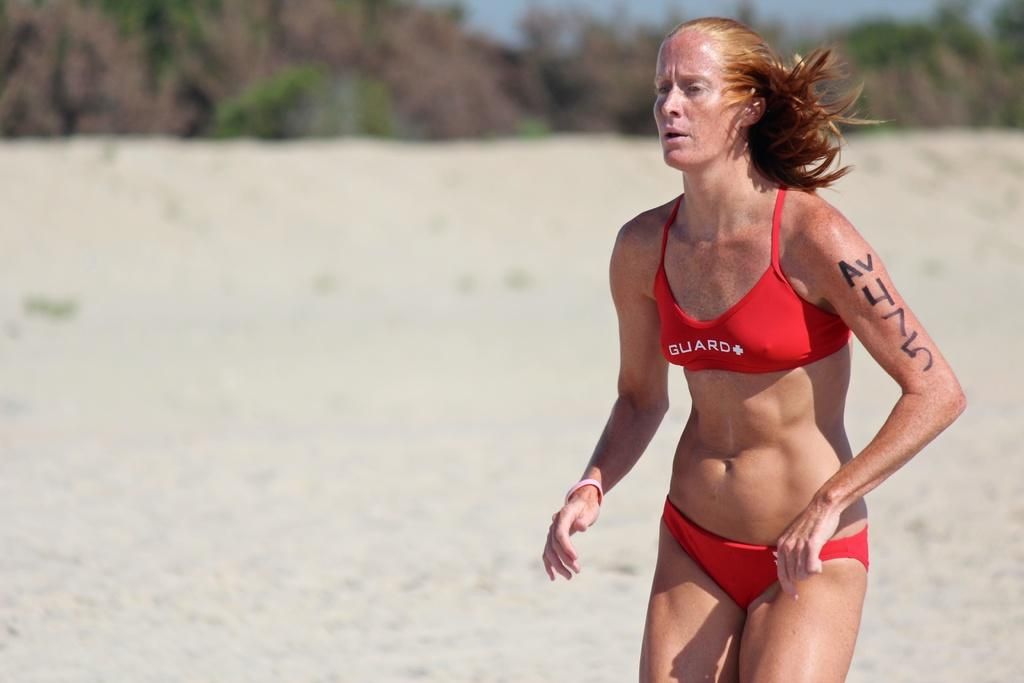Provide a one-sentence caption for the provided image. A woman on a beach wears an orange bikini with the word guard on the top. 